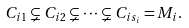Convert formula to latex. <formula><loc_0><loc_0><loc_500><loc_500>C _ { i 1 } \subsetneq C _ { i 2 } \subsetneq \cdots \subsetneq C _ { i s _ { i } } = M _ { i } .</formula> 